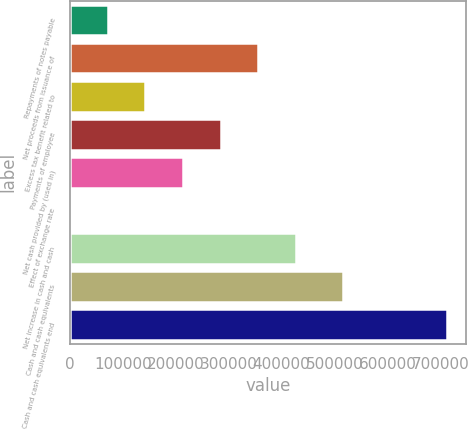Convert chart. <chart><loc_0><loc_0><loc_500><loc_500><bar_chart><fcel>Repayments of notes payable<fcel>Net proceeds from issuance of<fcel>Excess tax benefit related to<fcel>Payments of employee<fcel>Net cash provided by (used in)<fcel>Effect of exchange rate<fcel>Net increase in cash and cash<fcel>Cash and cash equivalents<fcel>Cash and cash equivalents end<nl><fcel>71596.8<fcel>356368<fcel>142790<fcel>285175<fcel>213982<fcel>404<fcel>427561<fcel>515625<fcel>712332<nl></chart> 